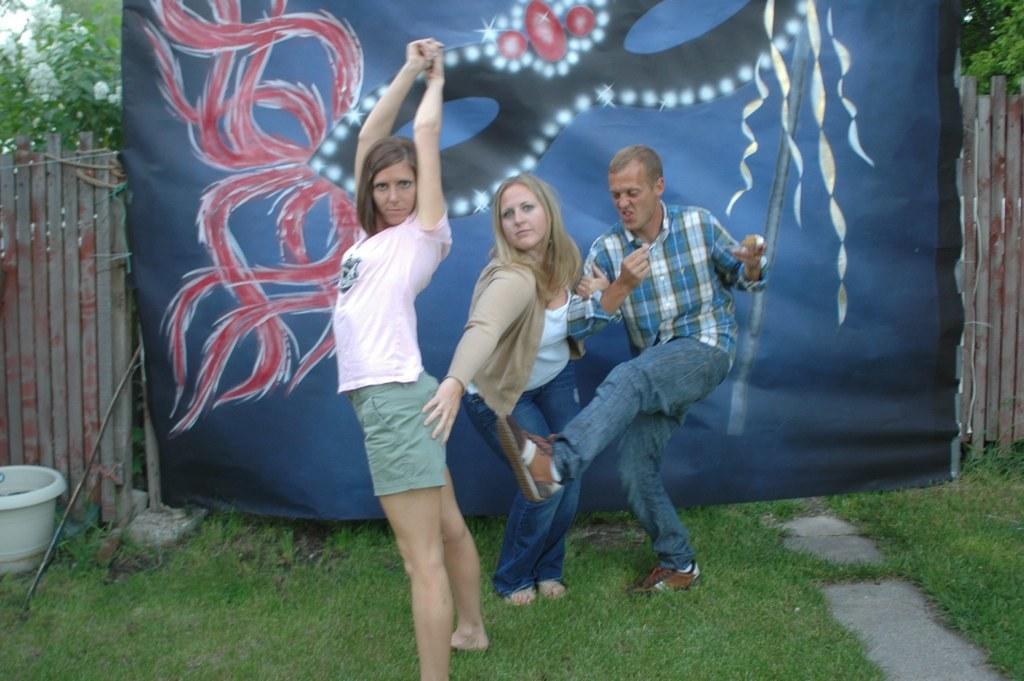How would you summarize this image in a sentence or two? There are three people standing. This looks like a banner with a design on it. I think this is a wooden fence. In the background, I can see the trees. On the left side of the image, that looks like a flower pot and a stick, which are placed on the grass. I think this is a pathway. 